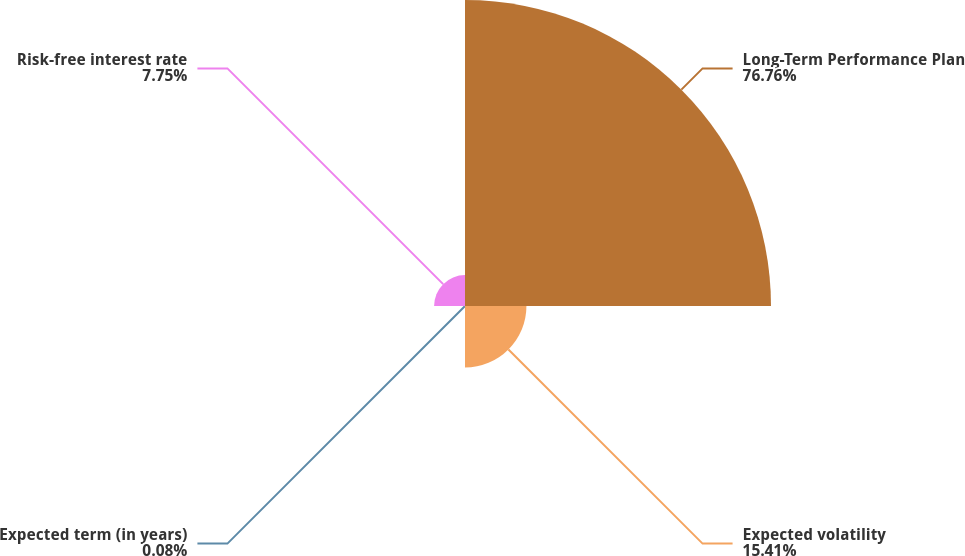<chart> <loc_0><loc_0><loc_500><loc_500><pie_chart><fcel>Long-Term Performance Plan<fcel>Expected volatility<fcel>Expected term (in years)<fcel>Risk-free interest rate<nl><fcel>76.76%<fcel>15.41%<fcel>0.08%<fcel>7.75%<nl></chart> 